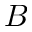<formula> <loc_0><loc_0><loc_500><loc_500>B</formula> 